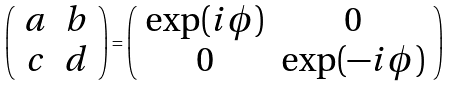<formula> <loc_0><loc_0><loc_500><loc_500>\left ( \begin{array} { c c } a & b \\ c & d \end{array} \right ) = \left ( \begin{array} { c c } \exp ( i \phi ) & 0 \\ 0 & \exp ( - i \phi ) \end{array} \right )</formula> 